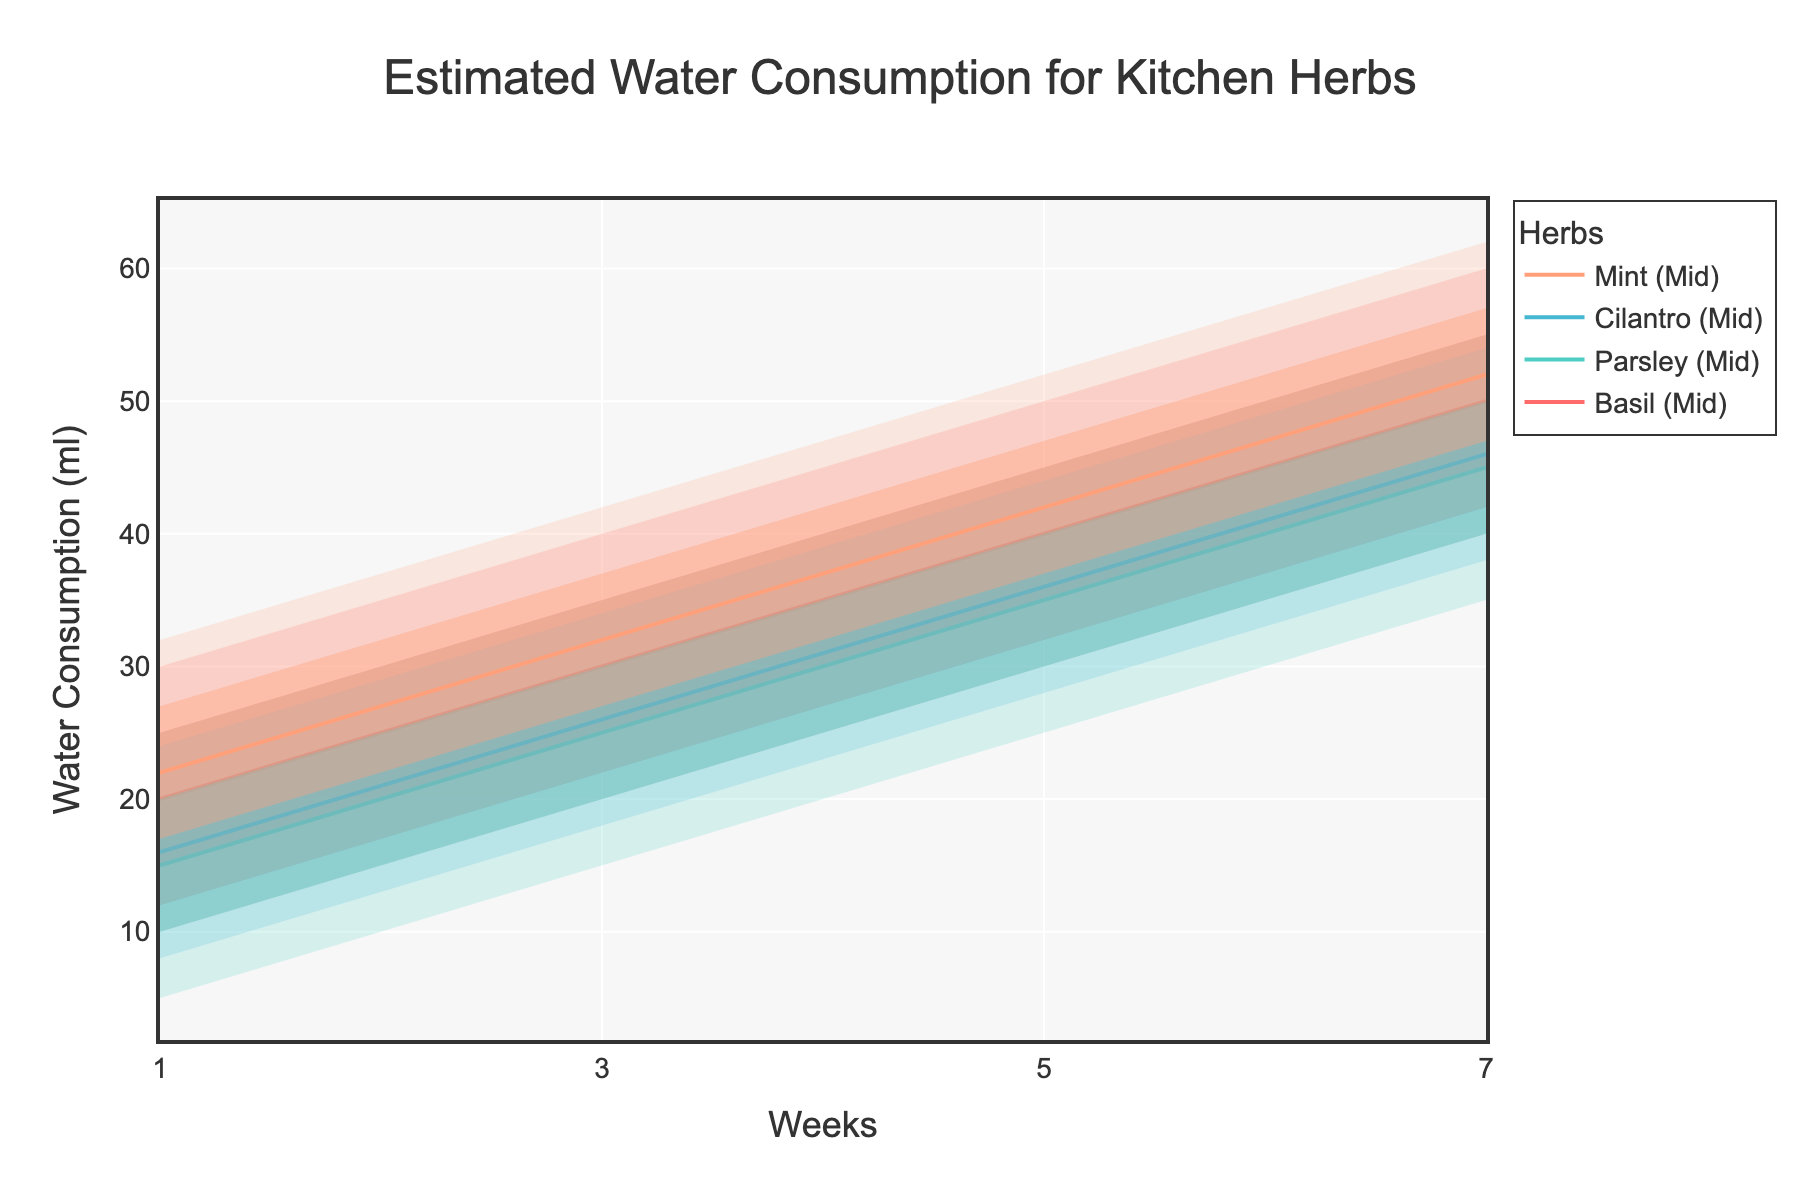Which herb has the highest estimated water consumption in week 1? Look at the data points for week 1 for each herb and compare the high values. Mint has the highest high value of 32 ml.
Answer: Mint What's the difference in high water consumption between Basil and Parsley in week 5? The high value for Basil in week 5 is 50 ml and for Parsley is 45 ml. The difference is 50 - 45 = 5 ml.
Answer: 5 ml In which week does Cilantro's mid water consumption reach 36 ml? Trace the mid water consumption values for Cilantro and find the week where the value is 36 ml, which is week 5.
Answer: Week 5 How does Mint's water consumption change from week 1 to week 7 for the high value? The high value for Mint starts at 32 ml in week 1 and increases to 62 ml in week 7. The change is calculated as 62 - 32 = 30 ml.
Answer: 30 ml What is the average low water consumption for Parsley from week 1 to week 7? Collect the low values for Parsley which are 5, 15, 25, and 35 ml. The average is (5 + 15 + 25 + 35) / 4 = 20 ml.
Answer: 20 ml Compare the mid water consumption of Basil and Mint in week 3. Which herb uses more water? The mid value for Basil is 30 ml while for Mint it is 32 ml in week 3. Mint uses more water.
Answer: Mint Which herb shows the steepest increase in high water consumption from week 1 to week 7? Calculate the increase for each herb: Basil (30 to 60), Parsley (25 to 55), Cilantro (24 to 54), and Mint (32 to 62). Mint has the steepest increase of 30 ml.
Answer: Mint In week 5, what is the range of estimated water consumption for Cilantro? The range is the difference between the high and low values: 44 - 28 = 16 ml.
Answer: 16 ml 